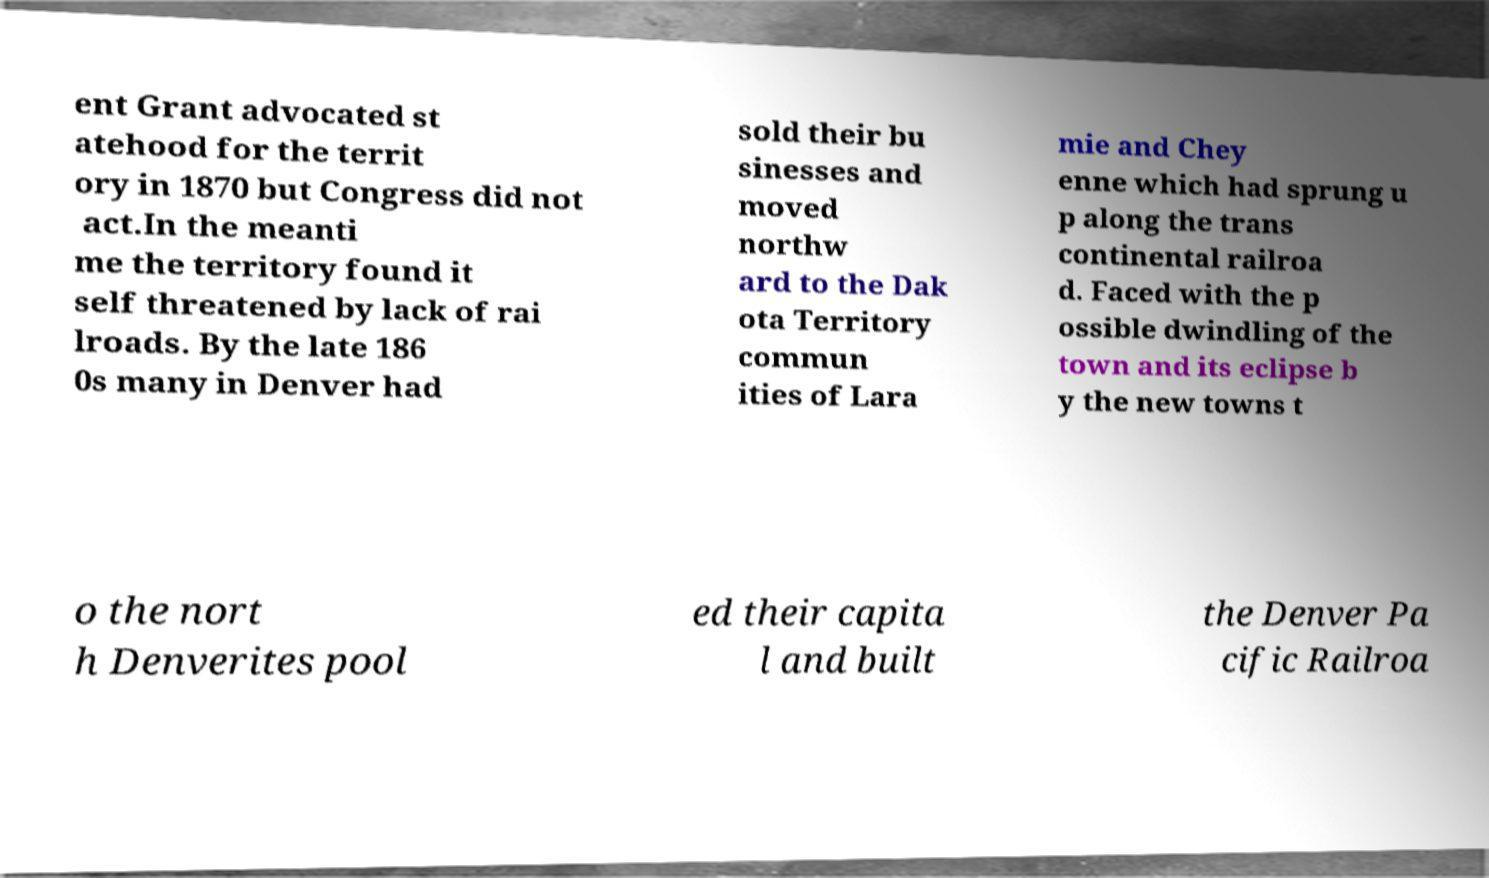Please identify and transcribe the text found in this image. ent Grant advocated st atehood for the territ ory in 1870 but Congress did not act.In the meanti me the territory found it self threatened by lack of rai lroads. By the late 186 0s many in Denver had sold their bu sinesses and moved northw ard to the Dak ota Territory commun ities of Lara mie and Chey enne which had sprung u p along the trans continental railroa d. Faced with the p ossible dwindling of the town and its eclipse b y the new towns t o the nort h Denverites pool ed their capita l and built the Denver Pa cific Railroa 